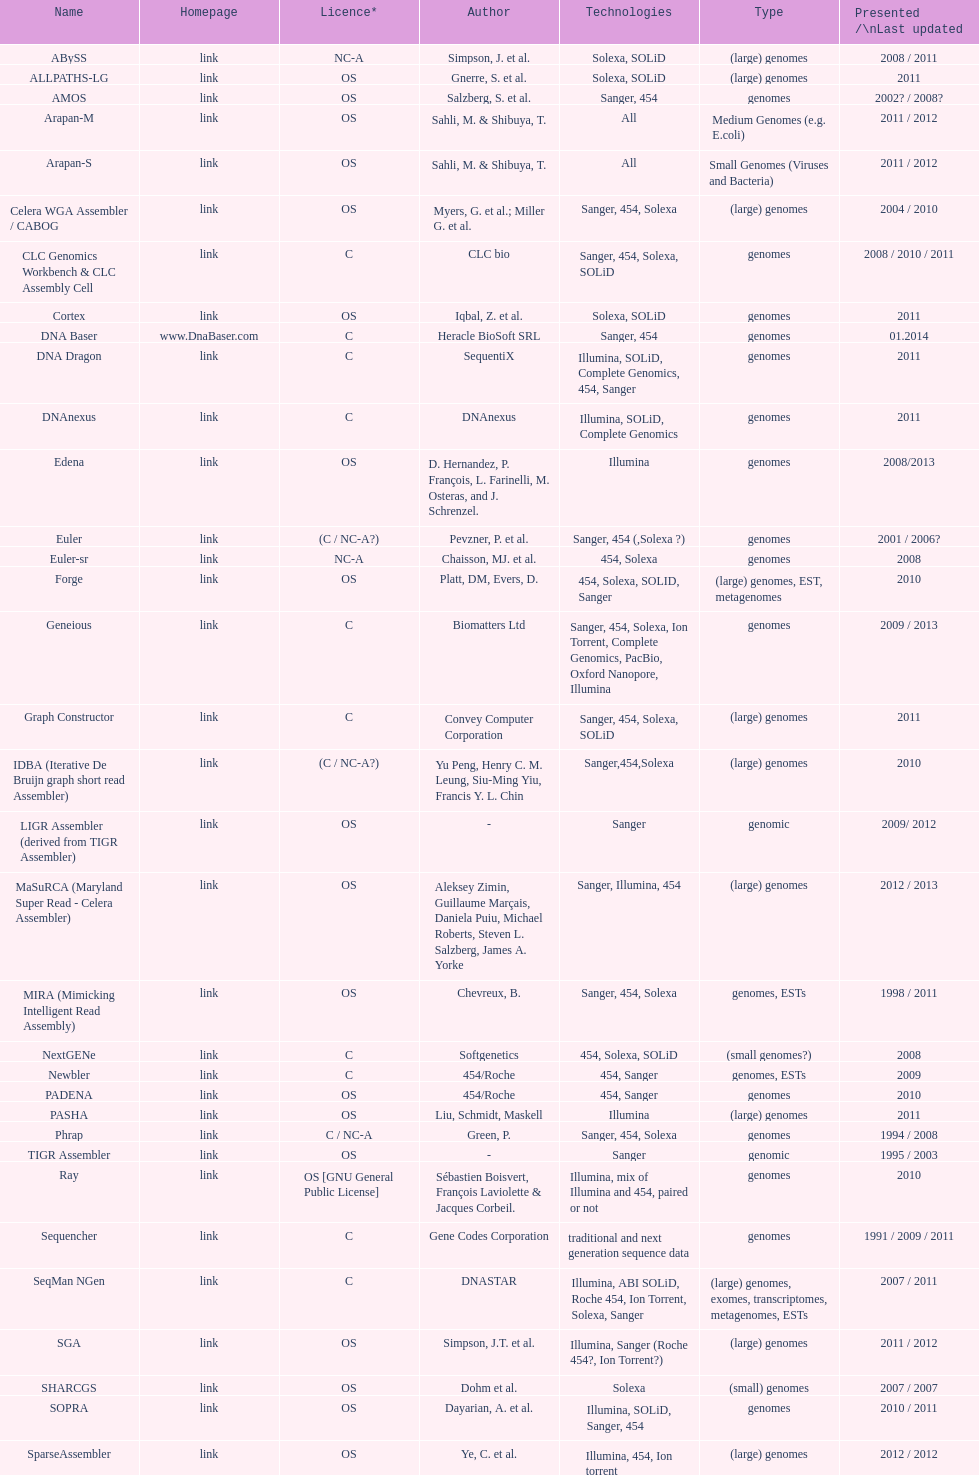What is the latest presentation or revised? DNA Baser. 